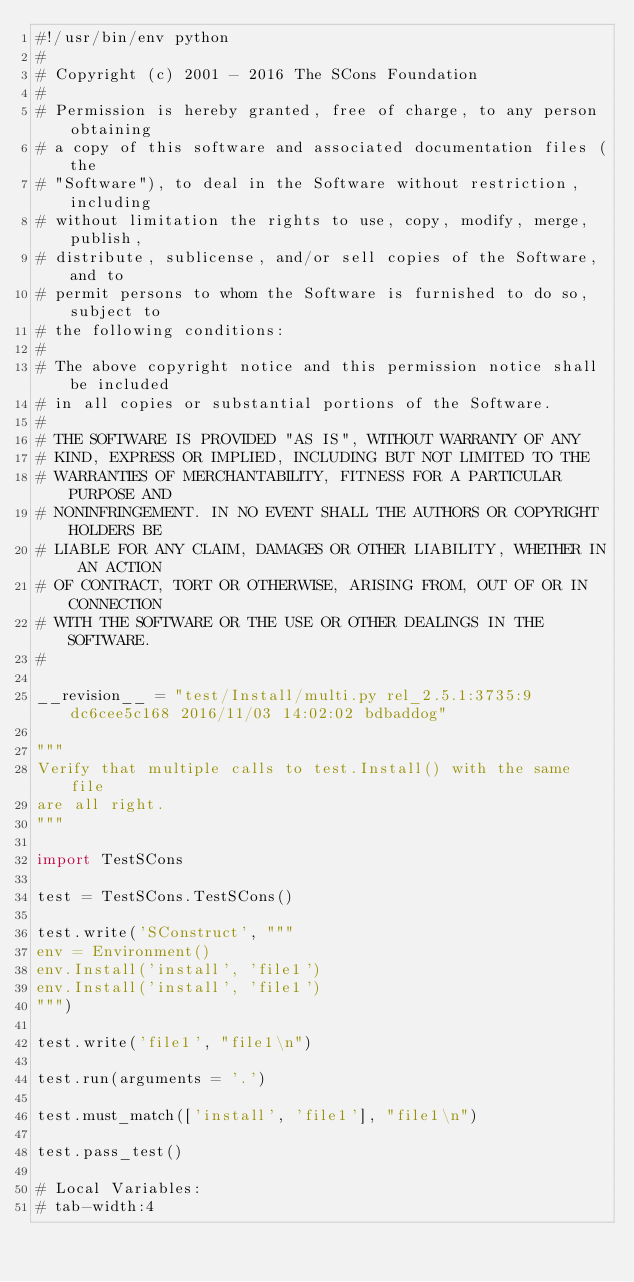Convert code to text. <code><loc_0><loc_0><loc_500><loc_500><_Python_>#!/usr/bin/env python
#
# Copyright (c) 2001 - 2016 The SCons Foundation
#
# Permission is hereby granted, free of charge, to any person obtaining
# a copy of this software and associated documentation files (the
# "Software"), to deal in the Software without restriction, including
# without limitation the rights to use, copy, modify, merge, publish,
# distribute, sublicense, and/or sell copies of the Software, and to
# permit persons to whom the Software is furnished to do so, subject to
# the following conditions:
#
# The above copyright notice and this permission notice shall be included
# in all copies or substantial portions of the Software.
#
# THE SOFTWARE IS PROVIDED "AS IS", WITHOUT WARRANTY OF ANY
# KIND, EXPRESS OR IMPLIED, INCLUDING BUT NOT LIMITED TO THE
# WARRANTIES OF MERCHANTABILITY, FITNESS FOR A PARTICULAR PURPOSE AND
# NONINFRINGEMENT. IN NO EVENT SHALL THE AUTHORS OR COPYRIGHT HOLDERS BE
# LIABLE FOR ANY CLAIM, DAMAGES OR OTHER LIABILITY, WHETHER IN AN ACTION
# OF CONTRACT, TORT OR OTHERWISE, ARISING FROM, OUT OF OR IN CONNECTION
# WITH THE SOFTWARE OR THE USE OR OTHER DEALINGS IN THE SOFTWARE.
#

__revision__ = "test/Install/multi.py rel_2.5.1:3735:9dc6cee5c168 2016/11/03 14:02:02 bdbaddog"

"""
Verify that multiple calls to test.Install() with the same file
are all right.
"""

import TestSCons

test = TestSCons.TestSCons()

test.write('SConstruct', """
env = Environment()
env.Install('install', 'file1')
env.Install('install', 'file1')
""")

test.write('file1', "file1\n")

test.run(arguments = '.')

test.must_match(['install', 'file1'], "file1\n")

test.pass_test()

# Local Variables:
# tab-width:4</code> 